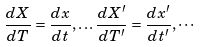Convert formula to latex. <formula><loc_0><loc_0><loc_500><loc_500>\frac { d X } { d T } = \frac { d x } { d t } , \dots \frac { d X ^ { \prime } } { d T ^ { \prime } } = \frac { d x ^ { \prime } } { d t ^ { \prime } } , \cdots</formula> 